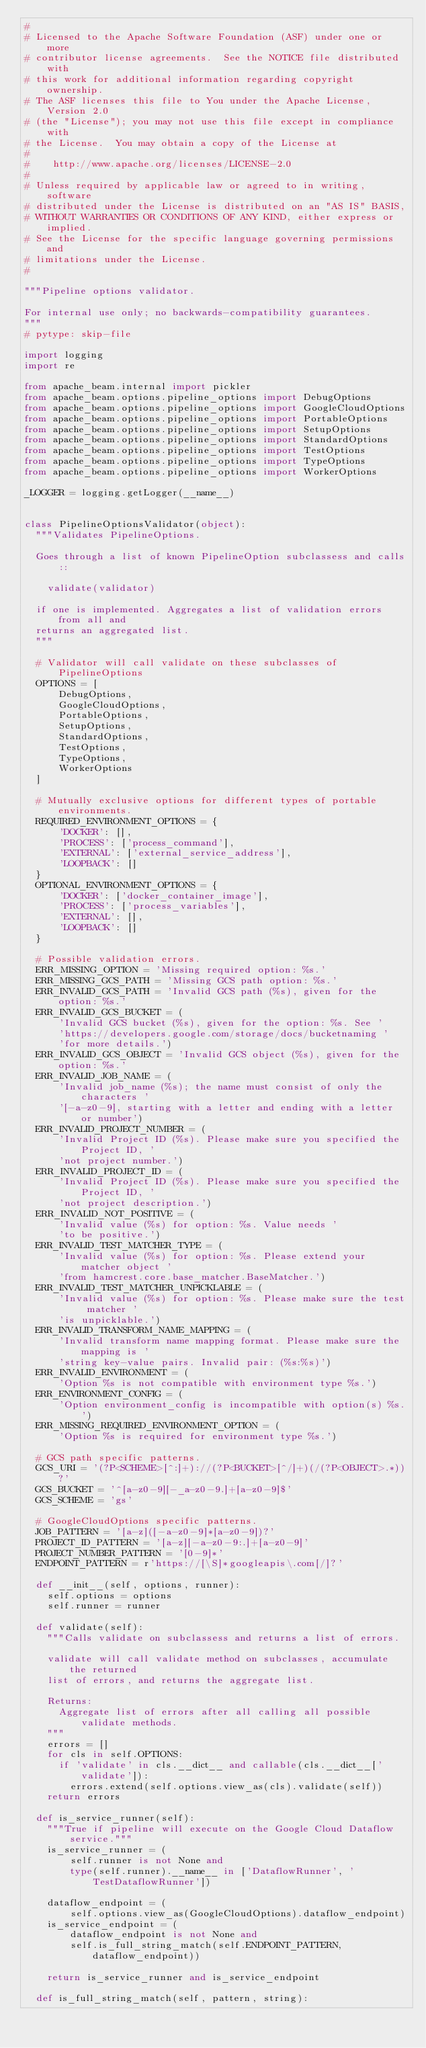<code> <loc_0><loc_0><loc_500><loc_500><_Python_>#
# Licensed to the Apache Software Foundation (ASF) under one or more
# contributor license agreements.  See the NOTICE file distributed with
# this work for additional information regarding copyright ownership.
# The ASF licenses this file to You under the Apache License, Version 2.0
# (the "License"); you may not use this file except in compliance with
# the License.  You may obtain a copy of the License at
#
#    http://www.apache.org/licenses/LICENSE-2.0
#
# Unless required by applicable law or agreed to in writing, software
# distributed under the License is distributed on an "AS IS" BASIS,
# WITHOUT WARRANTIES OR CONDITIONS OF ANY KIND, either express or implied.
# See the License for the specific language governing permissions and
# limitations under the License.
#

"""Pipeline options validator.

For internal use only; no backwards-compatibility guarantees.
"""
# pytype: skip-file

import logging
import re

from apache_beam.internal import pickler
from apache_beam.options.pipeline_options import DebugOptions
from apache_beam.options.pipeline_options import GoogleCloudOptions
from apache_beam.options.pipeline_options import PortableOptions
from apache_beam.options.pipeline_options import SetupOptions
from apache_beam.options.pipeline_options import StandardOptions
from apache_beam.options.pipeline_options import TestOptions
from apache_beam.options.pipeline_options import TypeOptions
from apache_beam.options.pipeline_options import WorkerOptions

_LOGGER = logging.getLogger(__name__)


class PipelineOptionsValidator(object):
  """Validates PipelineOptions.

  Goes through a list of known PipelineOption subclassess and calls::

    validate(validator)

  if one is implemented. Aggregates a list of validation errors from all and
  returns an aggregated list.
  """

  # Validator will call validate on these subclasses of PipelineOptions
  OPTIONS = [
      DebugOptions,
      GoogleCloudOptions,
      PortableOptions,
      SetupOptions,
      StandardOptions,
      TestOptions,
      TypeOptions,
      WorkerOptions
  ]

  # Mutually exclusive options for different types of portable environments.
  REQUIRED_ENVIRONMENT_OPTIONS = {
      'DOCKER': [],
      'PROCESS': ['process_command'],
      'EXTERNAL': ['external_service_address'],
      'LOOPBACK': []
  }
  OPTIONAL_ENVIRONMENT_OPTIONS = {
      'DOCKER': ['docker_container_image'],
      'PROCESS': ['process_variables'],
      'EXTERNAL': [],
      'LOOPBACK': []
  }

  # Possible validation errors.
  ERR_MISSING_OPTION = 'Missing required option: %s.'
  ERR_MISSING_GCS_PATH = 'Missing GCS path option: %s.'
  ERR_INVALID_GCS_PATH = 'Invalid GCS path (%s), given for the option: %s.'
  ERR_INVALID_GCS_BUCKET = (
      'Invalid GCS bucket (%s), given for the option: %s. See '
      'https://developers.google.com/storage/docs/bucketnaming '
      'for more details.')
  ERR_INVALID_GCS_OBJECT = 'Invalid GCS object (%s), given for the option: %s.'
  ERR_INVALID_JOB_NAME = (
      'Invalid job_name (%s); the name must consist of only the characters '
      '[-a-z0-9], starting with a letter and ending with a letter or number')
  ERR_INVALID_PROJECT_NUMBER = (
      'Invalid Project ID (%s). Please make sure you specified the Project ID, '
      'not project number.')
  ERR_INVALID_PROJECT_ID = (
      'Invalid Project ID (%s). Please make sure you specified the Project ID, '
      'not project description.')
  ERR_INVALID_NOT_POSITIVE = (
      'Invalid value (%s) for option: %s. Value needs '
      'to be positive.')
  ERR_INVALID_TEST_MATCHER_TYPE = (
      'Invalid value (%s) for option: %s. Please extend your matcher object '
      'from hamcrest.core.base_matcher.BaseMatcher.')
  ERR_INVALID_TEST_MATCHER_UNPICKLABLE = (
      'Invalid value (%s) for option: %s. Please make sure the test matcher '
      'is unpicklable.')
  ERR_INVALID_TRANSFORM_NAME_MAPPING = (
      'Invalid transform name mapping format. Please make sure the mapping is '
      'string key-value pairs. Invalid pair: (%s:%s)')
  ERR_INVALID_ENVIRONMENT = (
      'Option %s is not compatible with environment type %s.')
  ERR_ENVIRONMENT_CONFIG = (
      'Option environment_config is incompatible with option(s) %s.')
  ERR_MISSING_REQUIRED_ENVIRONMENT_OPTION = (
      'Option %s is required for environment type %s.')

  # GCS path specific patterns.
  GCS_URI = '(?P<SCHEME>[^:]+)://(?P<BUCKET>[^/]+)(/(?P<OBJECT>.*))?'
  GCS_BUCKET = '^[a-z0-9][-_a-z0-9.]+[a-z0-9]$'
  GCS_SCHEME = 'gs'

  # GoogleCloudOptions specific patterns.
  JOB_PATTERN = '[a-z]([-a-z0-9]*[a-z0-9])?'
  PROJECT_ID_PATTERN = '[a-z][-a-z0-9:.]+[a-z0-9]'
  PROJECT_NUMBER_PATTERN = '[0-9]*'
  ENDPOINT_PATTERN = r'https://[\S]*googleapis\.com[/]?'

  def __init__(self, options, runner):
    self.options = options
    self.runner = runner

  def validate(self):
    """Calls validate on subclassess and returns a list of errors.

    validate will call validate method on subclasses, accumulate the returned
    list of errors, and returns the aggregate list.

    Returns:
      Aggregate list of errors after all calling all possible validate methods.
    """
    errors = []
    for cls in self.OPTIONS:
      if 'validate' in cls.__dict__ and callable(cls.__dict__['validate']):
        errors.extend(self.options.view_as(cls).validate(self))
    return errors

  def is_service_runner(self):
    """True if pipeline will execute on the Google Cloud Dataflow service."""
    is_service_runner = (
        self.runner is not None and
        type(self.runner).__name__ in ['DataflowRunner', 'TestDataflowRunner'])

    dataflow_endpoint = (
        self.options.view_as(GoogleCloudOptions).dataflow_endpoint)
    is_service_endpoint = (
        dataflow_endpoint is not None and
        self.is_full_string_match(self.ENDPOINT_PATTERN, dataflow_endpoint))

    return is_service_runner and is_service_endpoint

  def is_full_string_match(self, pattern, string):</code> 